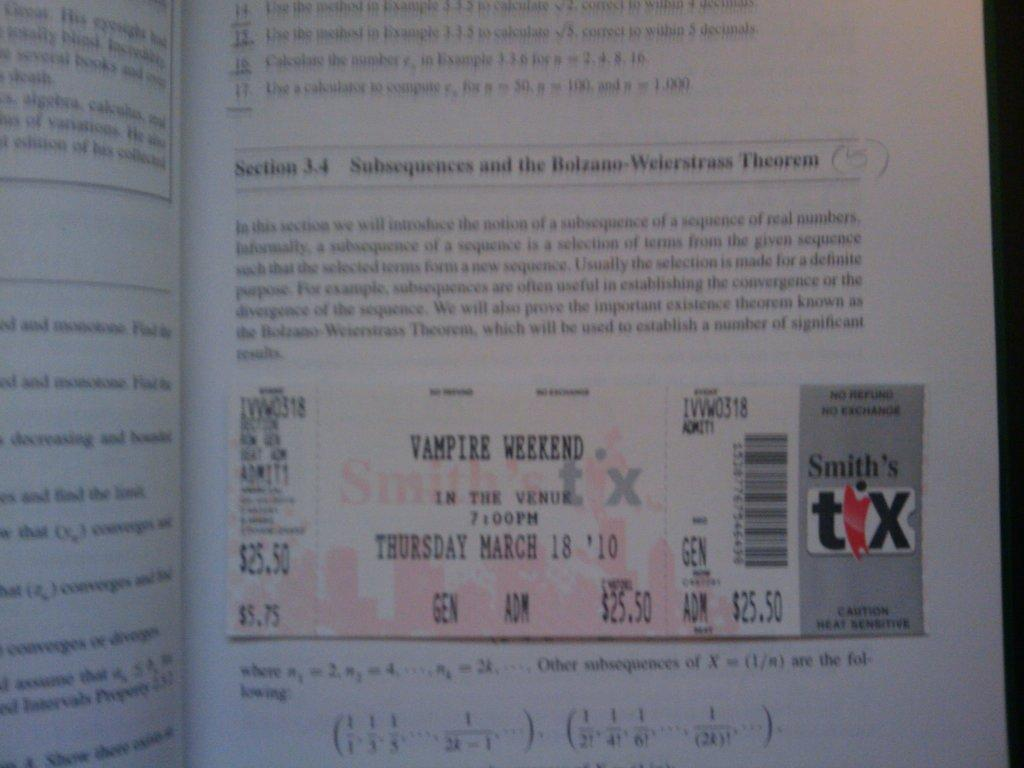Provide a one-sentence caption for the provided image. smith's tix movie ticket for vampire weekend laying against open math workbook. 